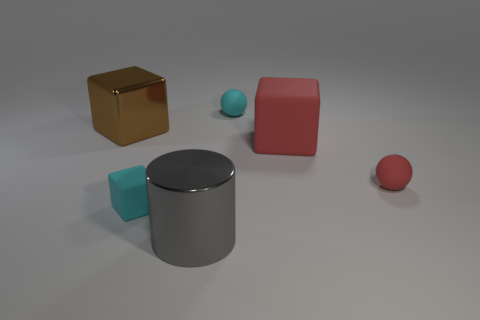There is a matte thing that is both to the left of the large red matte block and behind the cyan matte block; how big is it?
Keep it short and to the point. Small. There is a cyan thing that is the same shape as the big red matte object; what is its size?
Give a very brief answer. Small. There is a large object that is behind the big gray shiny thing and to the right of the tiny matte block; what is its color?
Provide a short and direct response. Red. What is the color of the big rubber object that is the same shape as the brown metal object?
Provide a succinct answer. Red. Do the large red matte object and the metal thing to the left of the large gray thing have the same shape?
Provide a succinct answer. Yes. What is the brown thing made of?
Offer a very short reply. Metal. Do the big matte object and the tiny rubber sphere that is in front of the metal block have the same color?
Make the answer very short. Yes. Is there any other thing that has the same shape as the brown shiny object?
Offer a very short reply. Yes. What number of objects have the same color as the tiny matte cube?
Keep it short and to the point. 1. What is the size of the cyan rubber sphere?
Provide a short and direct response. Small. 